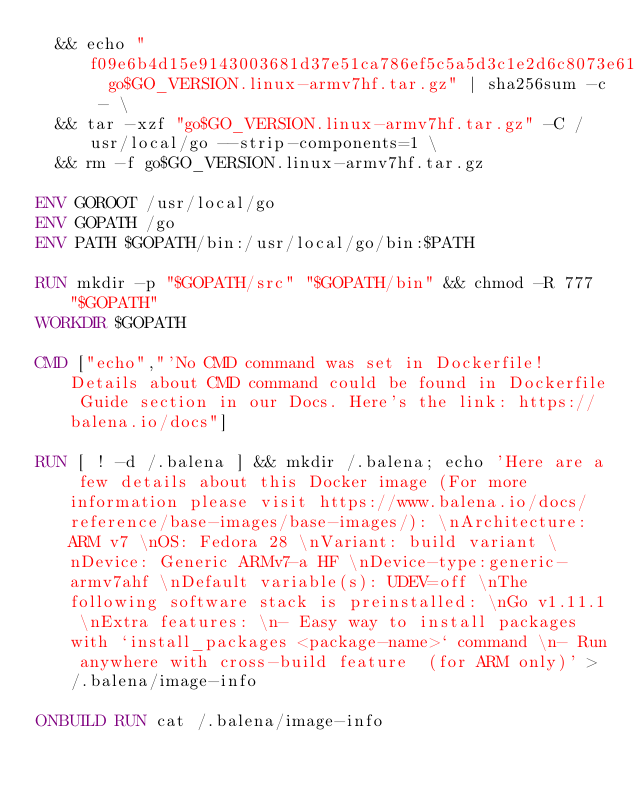Convert code to text. <code><loc_0><loc_0><loc_500><loc_500><_Dockerfile_>	&& echo "f09e6b4d15e9143003681d37e51ca786ef5c5a5d3c1e2d6c8073e61c823b8c1a  go$GO_VERSION.linux-armv7hf.tar.gz" | sha256sum -c - \
	&& tar -xzf "go$GO_VERSION.linux-armv7hf.tar.gz" -C /usr/local/go --strip-components=1 \
	&& rm -f go$GO_VERSION.linux-armv7hf.tar.gz

ENV GOROOT /usr/local/go
ENV GOPATH /go
ENV PATH $GOPATH/bin:/usr/local/go/bin:$PATH

RUN mkdir -p "$GOPATH/src" "$GOPATH/bin" && chmod -R 777 "$GOPATH"
WORKDIR $GOPATH

CMD ["echo","'No CMD command was set in Dockerfile! Details about CMD command could be found in Dockerfile Guide section in our Docs. Here's the link: https://balena.io/docs"]

RUN [ ! -d /.balena ] && mkdir /.balena; echo 'Here are a few details about this Docker image (For more information please visit https://www.balena.io/docs/reference/base-images/base-images/): \nArchitecture: ARM v7 \nOS: Fedora 28 \nVariant: build variant \nDevice: Generic ARMv7-a HF \nDevice-type:generic-armv7ahf \nDefault variable(s): UDEV=off \nThe following software stack is preinstalled: \nGo v1.11.1 \nExtra features: \n- Easy way to install packages with `install_packages <package-name>` command \n- Run anywhere with cross-build feature  (for ARM only)' > /.balena/image-info

ONBUILD RUN cat /.balena/image-info</code> 